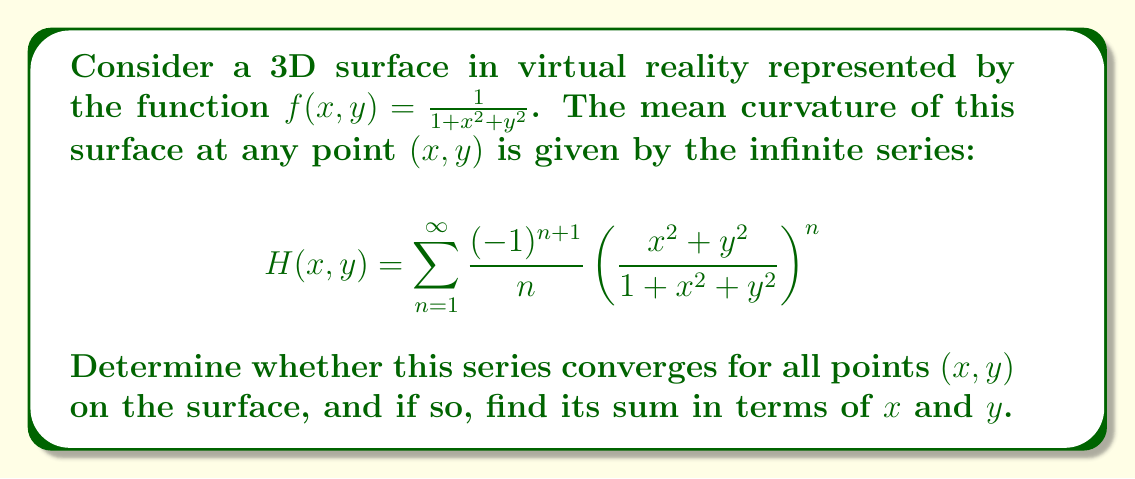Show me your answer to this math problem. To determine the convergence of this series and find its sum, we'll follow these steps:

1) First, let's examine the general term of the series:

   $$a_n = \frac{(-1)^{n+1}}{n} \left(\frac{x^2+y^2}{1+x^2+y^2}\right)^n$$

2) Notice that this is an alternating series. We can apply the alternating series test if we can show that:
   a) $|a_n|$ is decreasing
   b) $\lim_{n \to \infty} |a_n| = 0$

3) Let's define $r = \frac{x^2+y^2}{1+x^2+y^2}$. Note that $0 \leq r < 1$ for all real $x$ and $y$.

4) Now we can rewrite $|a_n|$ as:

   $$|a_n| = \frac{1}{n} r^n$$

5) To show that $|a_n|$ is decreasing, we need to prove that $|a_{n+1}| < |a_n|$:

   $$\frac{1}{n+1} r^{n+1} < \frac{1}{n} r^n$$
   $$r < \left(\frac{n+1}{n}\right)^{\frac{1}{n}}$$

   This inequality holds for all $n \geq 1$ and $0 \leq r < 1$.

6) Now, let's check the limit:

   $$\lim_{n \to \infty} |a_n| = \lim_{n \to \infty} \frac{1}{n} r^n = 0$$

   This is true because $r < 1$.

7) Since both conditions of the alternating series test are satisfied, the series converges for all points $(x,y)$ on the surface.

8) To find the sum of the series, we can recognize that this is a well-known series expansion:

   $$\sum_{n=1}^{\infty} \frac{(-1)^{n+1}}{n} z^n = -\ln(1-z)$$, for $|z| < 1$

9) In our case, $z = \frac{x^2+y^2}{1+x^2+y^2}$, so the sum of the series is:

   $$H(x,y) = -\ln\left(1-\frac{x^2+y^2}{1+x^2+y^2}\right) = -\ln\left(\frac{1}{1+x^2+y^2}\right) = \ln(1+x^2+y^2)$$

Therefore, the series converges for all points $(x,y)$ on the surface, and its sum is $\ln(1+x^2+y^2)$.
Answer: $\ln(1+x^2+y^2)$ 